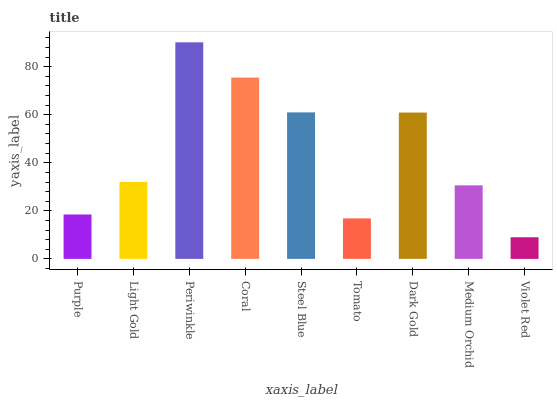Is Violet Red the minimum?
Answer yes or no. Yes. Is Periwinkle the maximum?
Answer yes or no. Yes. Is Light Gold the minimum?
Answer yes or no. No. Is Light Gold the maximum?
Answer yes or no. No. Is Light Gold greater than Purple?
Answer yes or no. Yes. Is Purple less than Light Gold?
Answer yes or no. Yes. Is Purple greater than Light Gold?
Answer yes or no. No. Is Light Gold less than Purple?
Answer yes or no. No. Is Light Gold the high median?
Answer yes or no. Yes. Is Light Gold the low median?
Answer yes or no. Yes. Is Steel Blue the high median?
Answer yes or no. No. Is Periwinkle the low median?
Answer yes or no. No. 